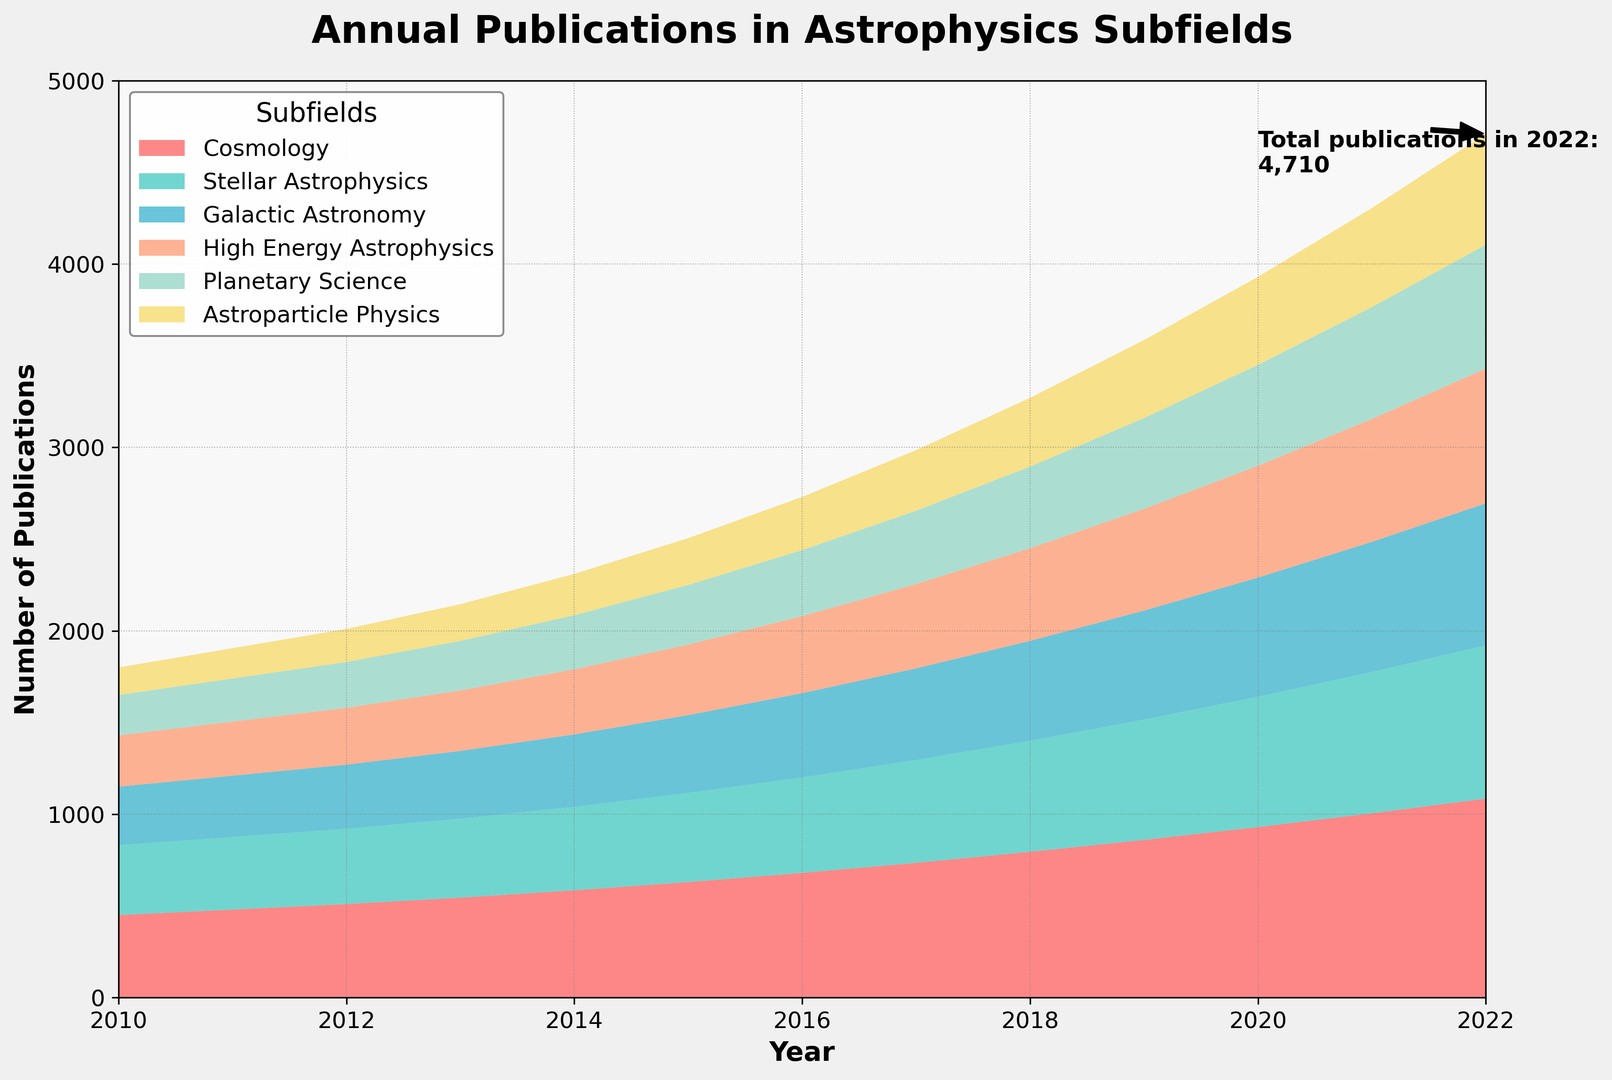How many publications in Cosmology were there in 2015? To find the number of publications in Cosmology for the year 2015, locate the value at the intersection of the "Cosmology" row and the "2015" column.
Answer: 630 Which subfield had the highest number of publications in 2022? Look at the values for each subfield in the year 2022 and find the highest one.
Answer: Cosmology By how much did the total number of publications in Galactic Astronomy increase from 2010 to 2022? Calculate the difference between the number of publications in Galactic Astronomy in 2022 and 2010. The values are 775 (2022) and 320 (2010).
Answer: 455 What was the combined number of publications in High Energy Astrophysics and Planetary Science in 2018? Add the number of publications in High Energy Astrophysics and Planetary Science for the year 2018. The values are 505 (High Energy Astrophysics) and 445 (Planetary Science).
Answer: 950 Which subfield showed the most consistent year-on-year growth? To determine consistency, visually check which subfield has a smooth and steady increase in the area chart without sharp changes over the years.
Answer: Cosmology Compare the number of publications in Astroparticle Physics and Stellar Astrophysics in 2010. Which one had more, and by how much? Look at the values for Astroparticle Physics and Stellar Astrophysics in 2010. Subtract the smaller value from the larger one. The values are 150 (Astroparticle Physics) and 380 (Stellar Astrophysics).
Answer: Stellar Astrophysics had more by 230 Which subfield experienced the most significant increase in publication numbers from 2010 to 2022 in absolute terms? Compute the difference in publication numbers from 2010 to 2022 for each subfield and identify the subfield with the largest difference. The difference for Cosmology is 635, the largest.
Answer: Cosmology In which year did the total number of publications across all subfields first exceed 3000? Sum the publications across all subfields for each year and identify the first year the total exceeds 3000. This happens in 2014, where the total sum is 2310.
Answer: 2018 How did the number of publications in Planetary Science change from 2016 to 2019? Calculate the difference between the number of publications in Planetary Science in 2019 and 2016. The values are 495 (2019) and 360 (2016).
Answer: Increased by 135 Between 2011 and 2017, which subfield had the greatest percentage increase in publications? Calculate the percentage increase for each subfield from 2011 to 2017, and identify the subfield with the highest value. Percentage increase = [(Value in 2017 - Value in 2011) / Value in 2011] * 100. The highest percentage increase is for Astroparticle Physics: [(330 - 165) / 165] * 100 = 100%.
Answer: Astroparticle Physics 